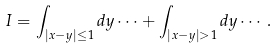Convert formula to latex. <formula><loc_0><loc_0><loc_500><loc_500>I = \int _ { | x - y | \leq 1 } d y \cdots + \int _ { | x - y | > 1 } d y \cdots .</formula> 